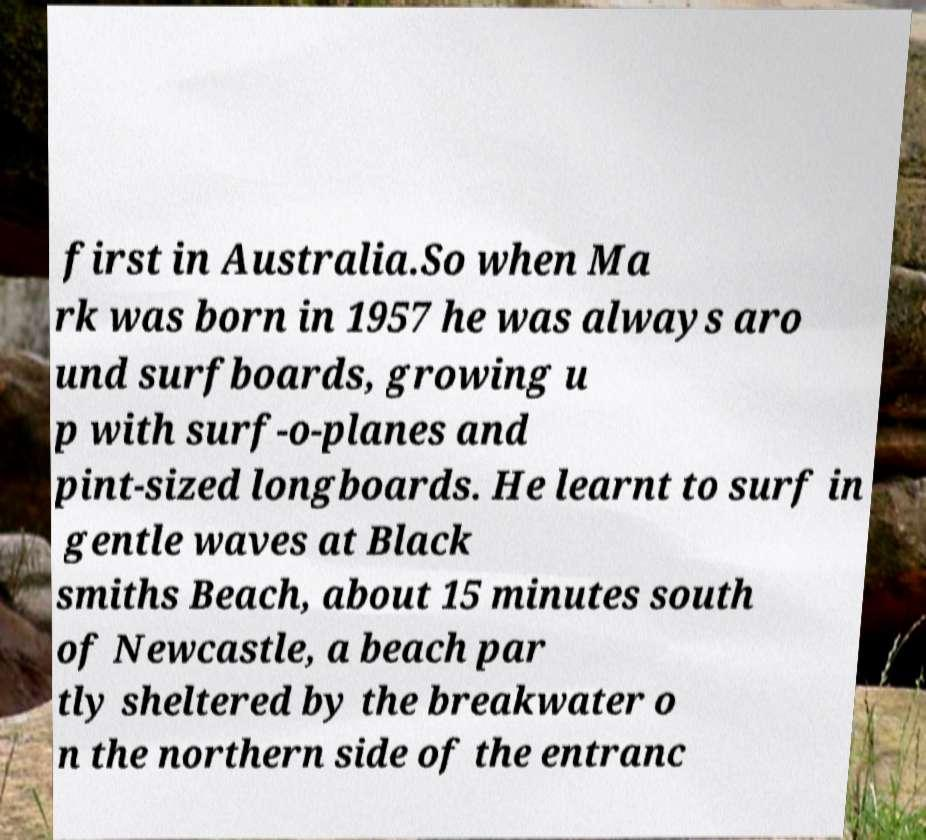I need the written content from this picture converted into text. Can you do that? first in Australia.So when Ma rk was born in 1957 he was always aro und surfboards, growing u p with surf-o-planes and pint-sized longboards. He learnt to surf in gentle waves at Black smiths Beach, about 15 minutes south of Newcastle, a beach par tly sheltered by the breakwater o n the northern side of the entranc 